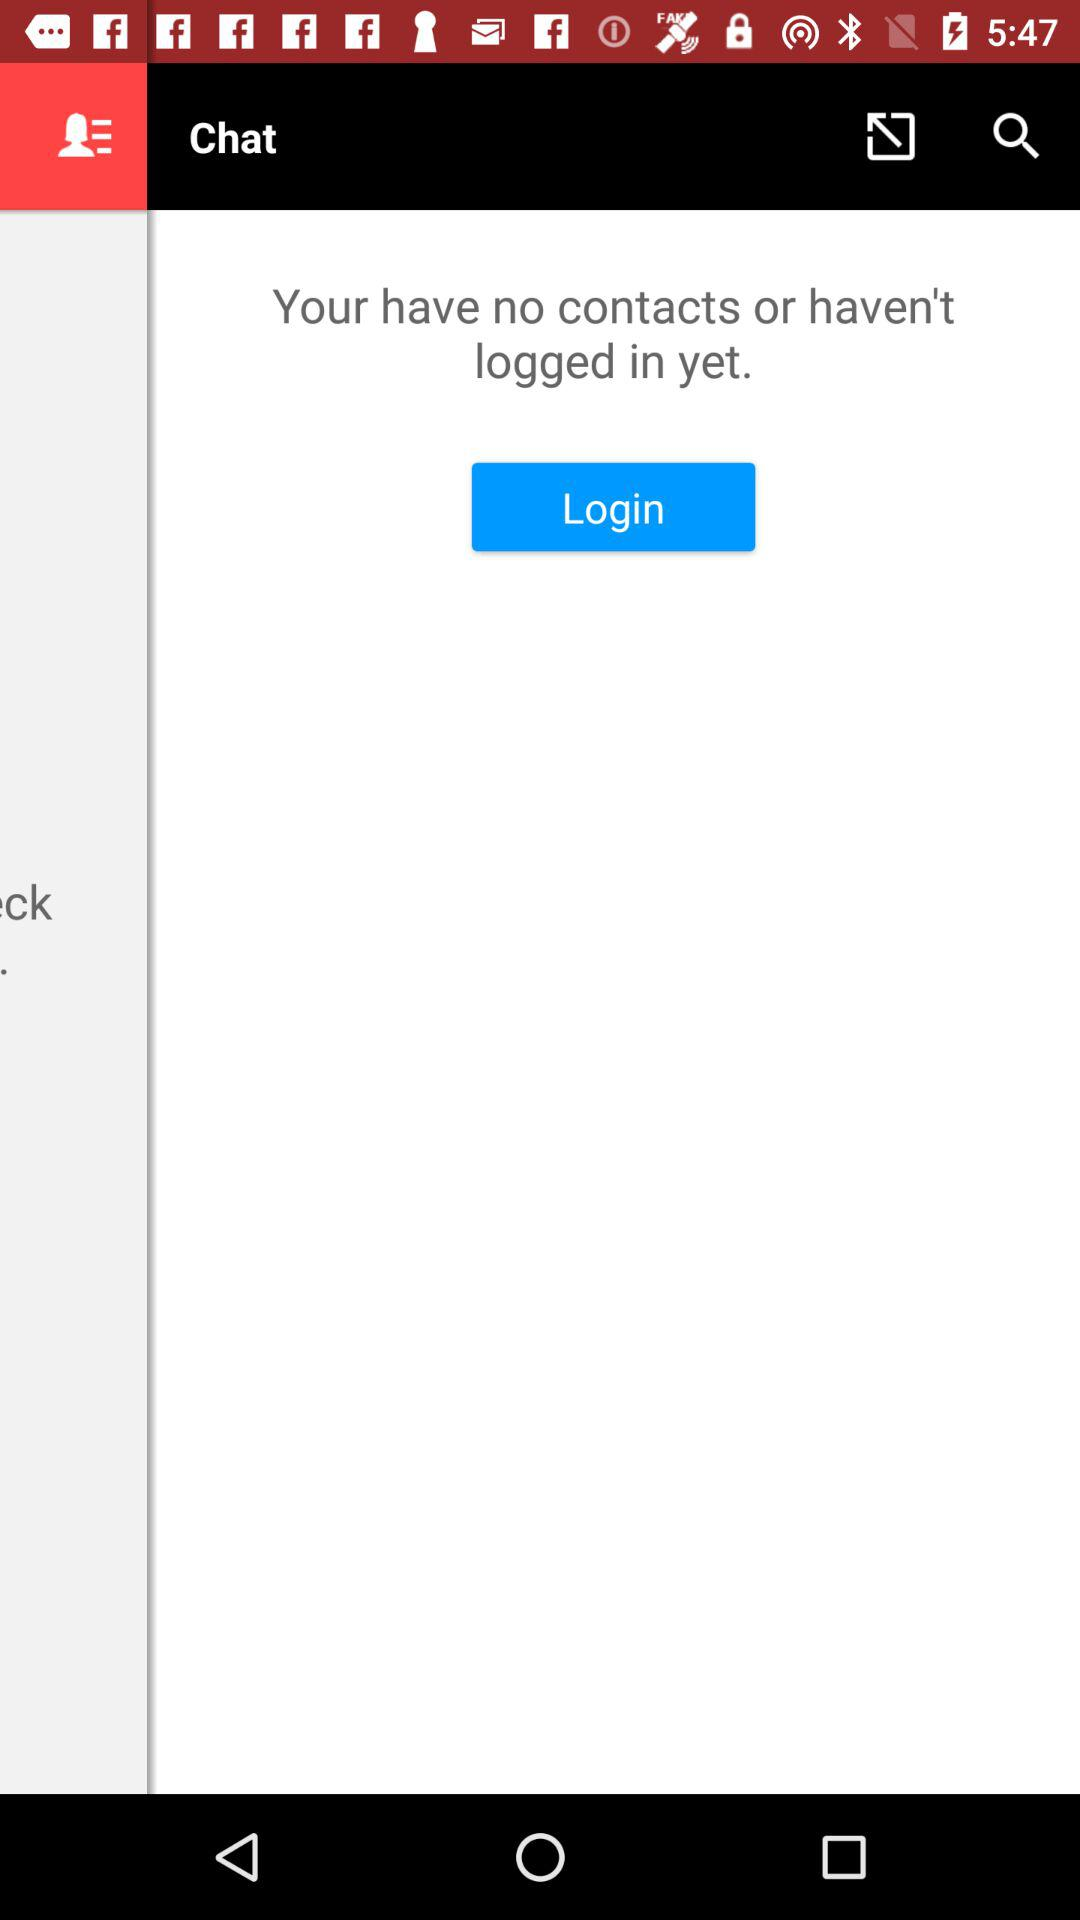Who is the user?
When the provided information is insufficient, respond with <no answer>. <no answer> 